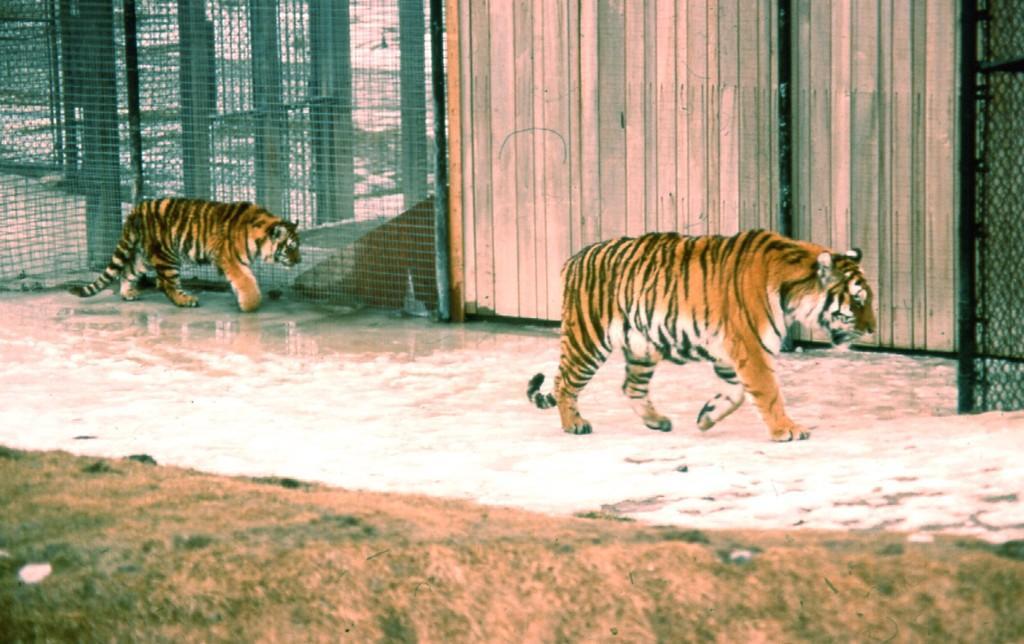Describe this image in one or two sentences. In this image there are tigers walking on a floor, in the background there is fencing and a wooden wall, at the bottom there is a grassland. 